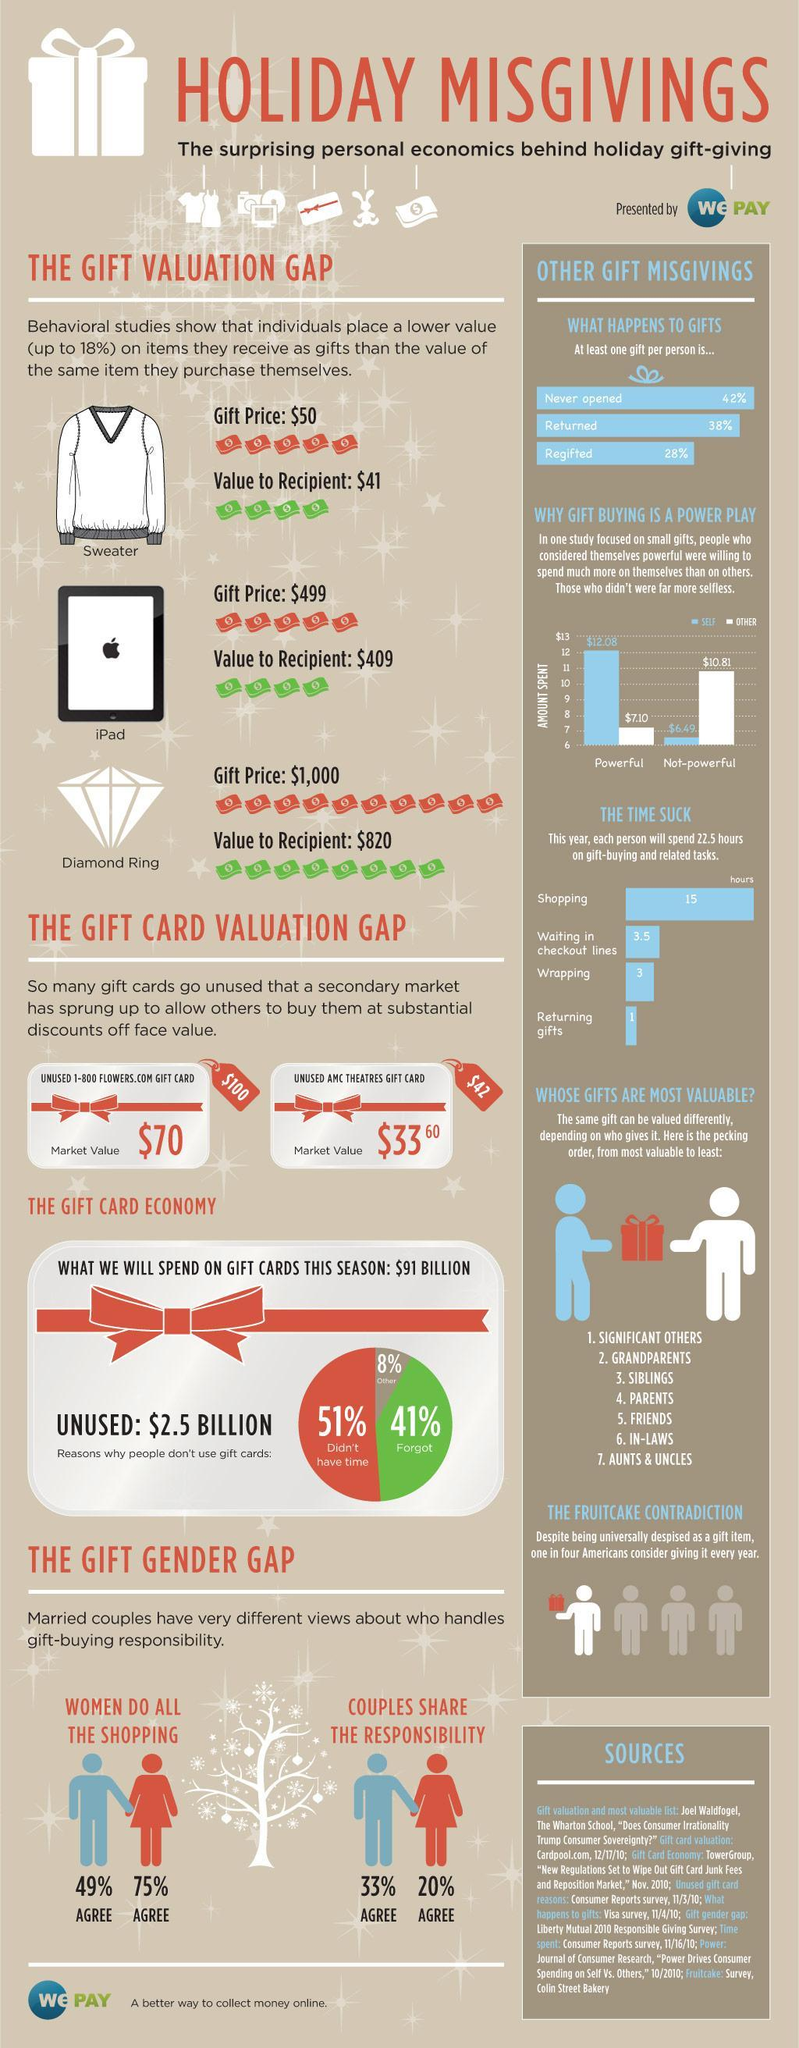How much less in $ is the value perceived by the recipient of a sweater as a gift than its actual value
Answer the question with a short phrase. 9 How much less in $ is the value perceived by the recipient of an iPad as a gift than its actual value 90 What % of people either forget or have other reasons for not using the gift card 49 How many total hours will people spend wrapping gifts or waiting in checkout lines 6.5 how much less in $ will be the market value of an unused flowers.com gift card than its actual card value 30 How much less in $ is the value perceived by the recipient of a diamond ring as a gift than its actual value 180 What are the 2 aspects considered in the gift gender gap analysis Women do all the shopping, Couples share the responsibility How much more amount in $ did the powerful spend on themselves than on others 4.98 